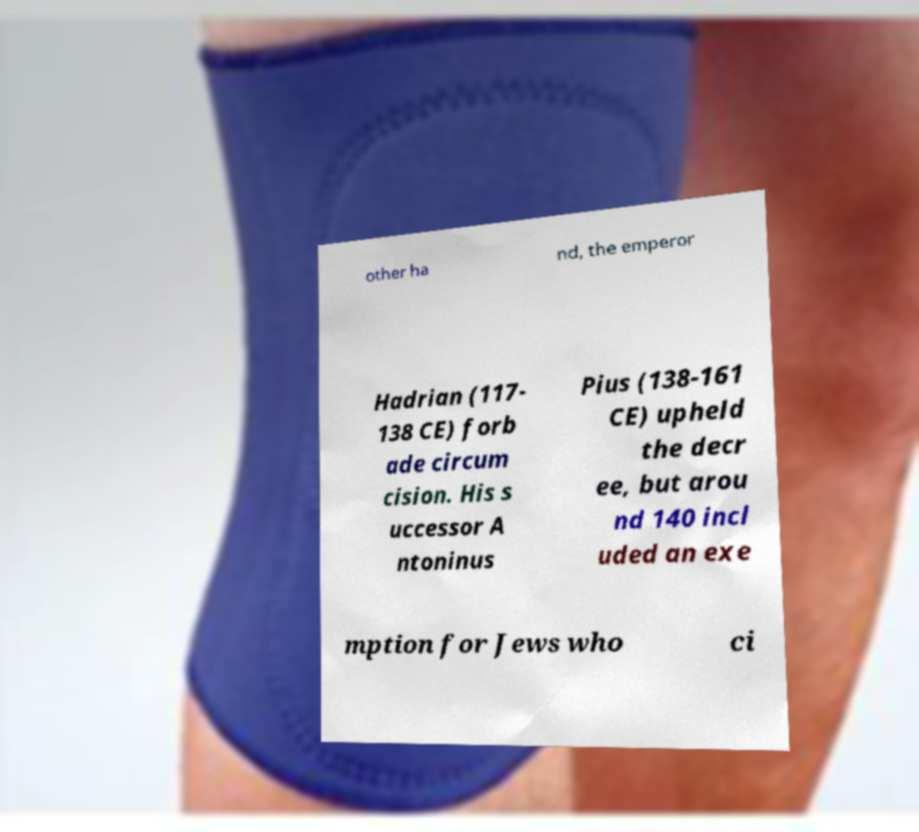Please read and relay the text visible in this image. What does it say? other ha nd, the emperor Hadrian (117- 138 CE) forb ade circum cision. His s uccessor A ntoninus Pius (138-161 CE) upheld the decr ee, but arou nd 140 incl uded an exe mption for Jews who ci 